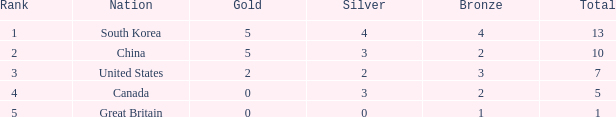Parse the table in full. {'header': ['Rank', 'Nation', 'Gold', 'Silver', 'Bronze', 'Total'], 'rows': [['1', 'South Korea', '5', '4', '4', '13'], ['2', 'China', '5', '3', '2', '10'], ['3', 'United States', '2', '2', '3', '7'], ['4', 'Canada', '0', '3', '2', '5'], ['5', 'Great Britain', '0', '0', '1', '1']]} What is the median silver, when rank is 5, and when bronze is lesser than 1? None. 